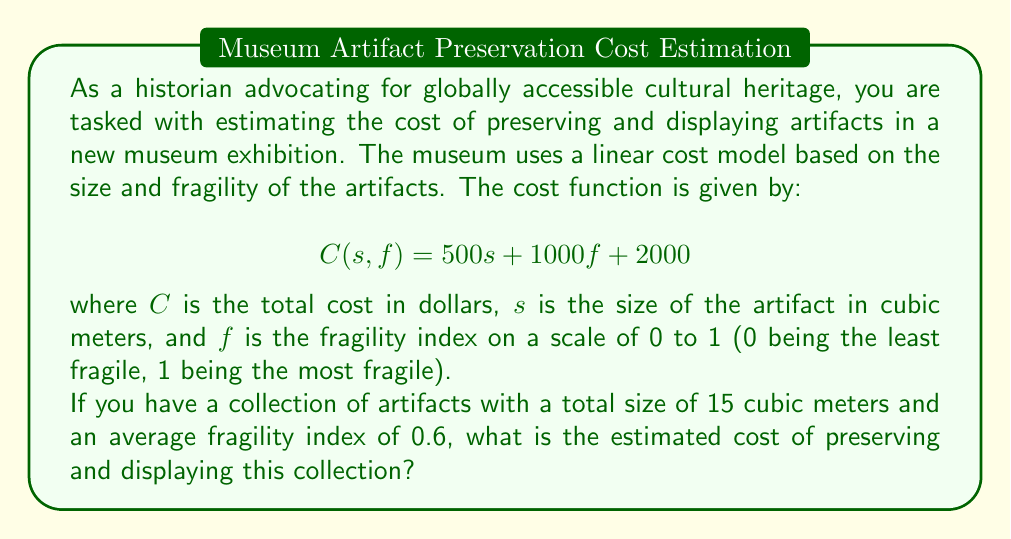Show me your answer to this math problem. To solve this problem, we need to follow these steps:

1. Identify the given information:
   - Total size of artifacts: $s = 15$ cubic meters
   - Average fragility index: $f = 0.6$
   - Cost function: $C(s, f) = 500s + 1000f + 2000$

2. Substitute the values into the cost function:
   $$C(15, 0.6) = 500(15) + 1000(0.6) + 2000$$

3. Solve the equation:
   $$C(15, 0.6) = 7500 + 600 + 2000$$
   $$C(15, 0.6) = 10100$$

Therefore, the estimated cost of preserving and displaying this collection of artifacts is $10,100.

This linear cost model takes into account both the size and fragility of the artifacts, which are crucial factors in determining preservation and display costs. The size affects storage and exhibition space requirements, while fragility impacts the level of care and specialized equipment needed for preservation.
Answer: $10,100 